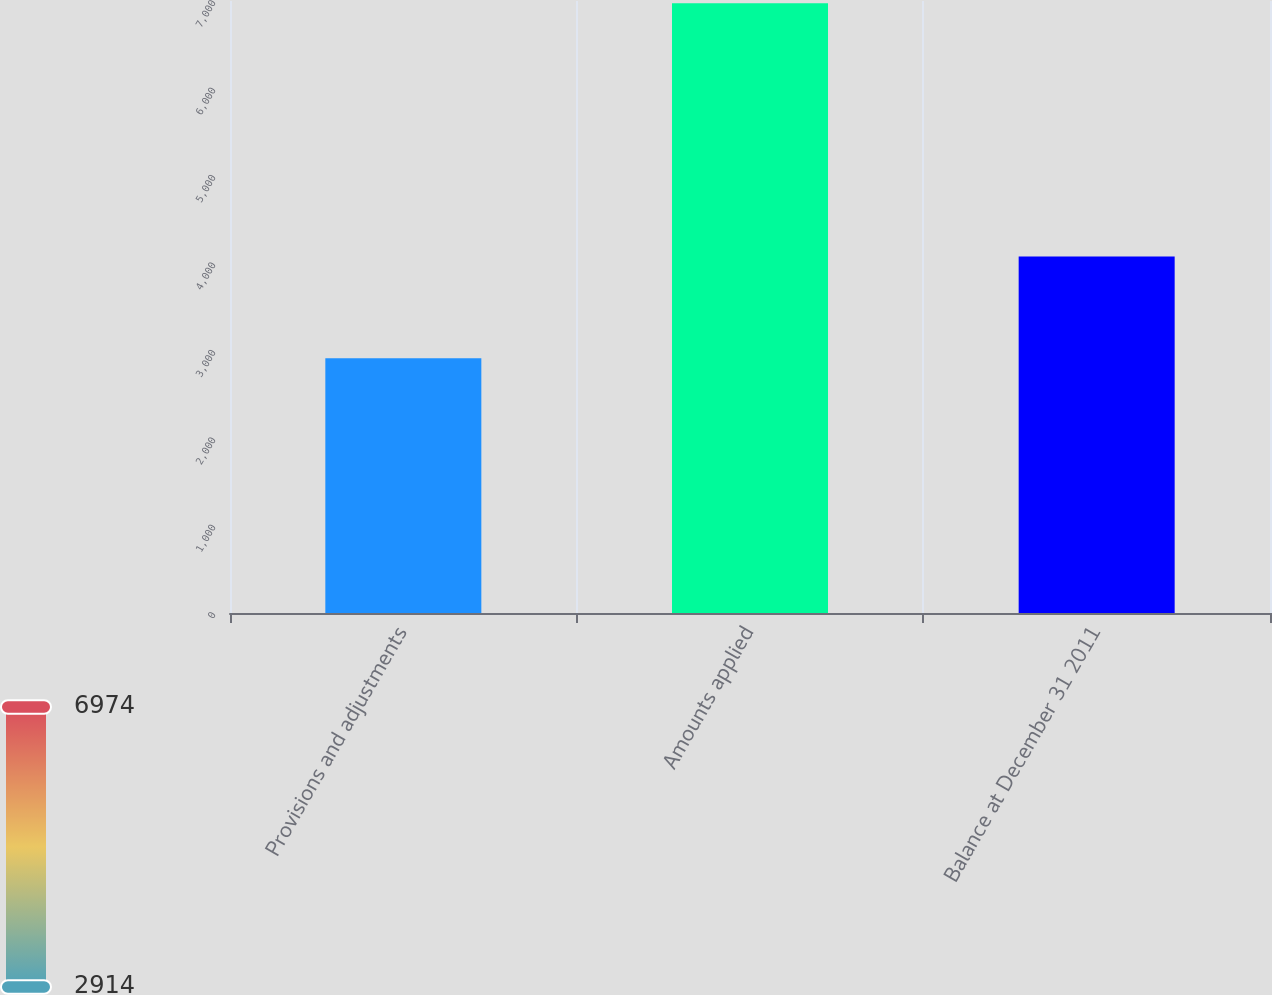Convert chart to OTSL. <chart><loc_0><loc_0><loc_500><loc_500><bar_chart><fcel>Provisions and adjustments<fcel>Amounts applied<fcel>Balance at December 31 2011<nl><fcel>2914<fcel>6974<fcel>4078<nl></chart> 